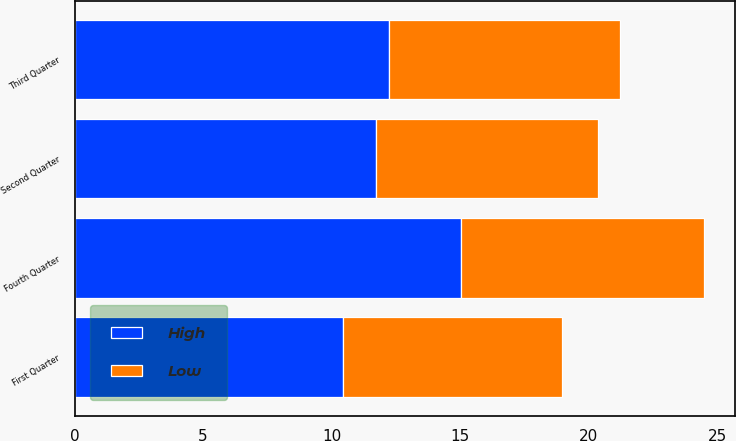Convert chart. <chart><loc_0><loc_0><loc_500><loc_500><stacked_bar_chart><ecel><fcel>First Quarter<fcel>Second Quarter<fcel>Third Quarter<fcel>Fourth Quarter<nl><fcel>High<fcel>10.46<fcel>11.73<fcel>12.25<fcel>15.05<nl><fcel>Low<fcel>8.5<fcel>8.63<fcel>8.97<fcel>9.42<nl></chart> 